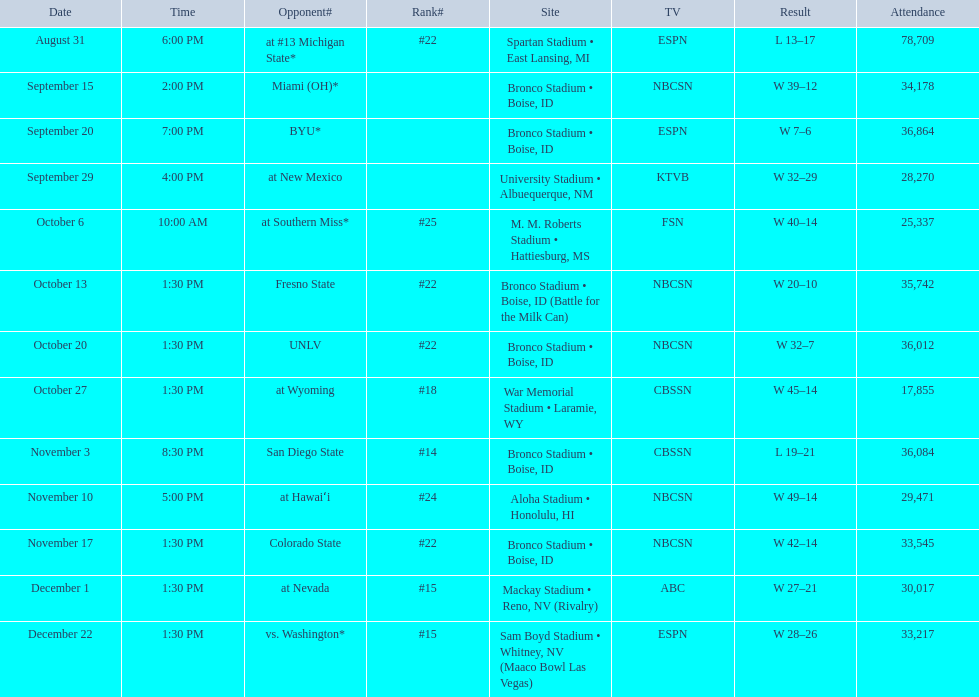What are the rival teams of the 2012 boise state broncos football team? At #13 michigan state*, miami (oh)*, byu*, at new mexico, at southern miss*, fresno state, unlv, at wyoming, san diego state, at hawaiʻi, colorado state, at nevada, vs. washington*. Which one has the highest rank among these opponents? San Diego State. 